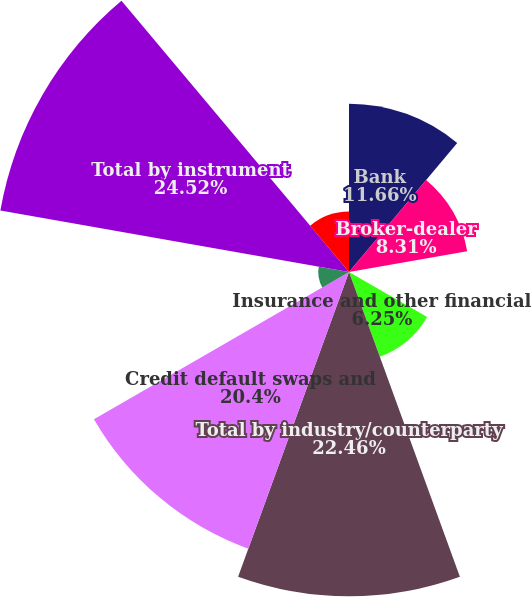<chart> <loc_0><loc_0><loc_500><loc_500><pie_chart><fcel>Bank<fcel>Broker-dealer<fcel>Non-financial<fcel>Insurance and other financial<fcel>Total by industry/counterparty<fcel>Credit default swaps and<fcel>Total return swaps and other<fcel>Total by instrument<fcel>Monoline<nl><fcel>11.66%<fcel>8.31%<fcel>0.08%<fcel>6.25%<fcel>22.46%<fcel>20.4%<fcel>2.13%<fcel>24.52%<fcel>4.19%<nl></chart> 